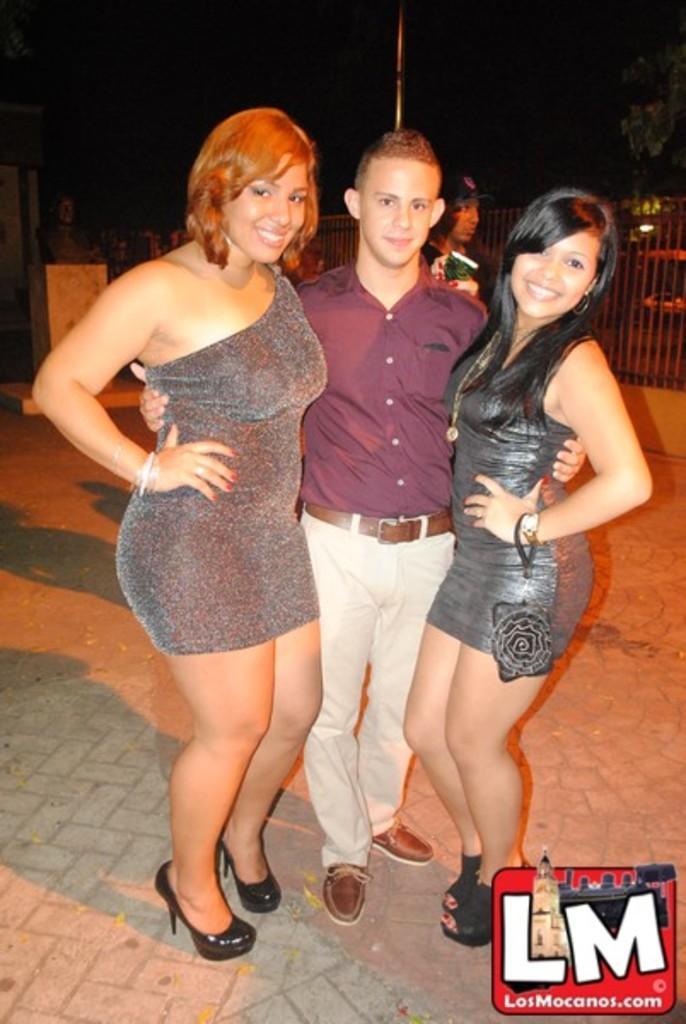How would you summarize this image in a sentence or two? In this picture we can see people standing on the ground and in the background we can see a fence,sky. 